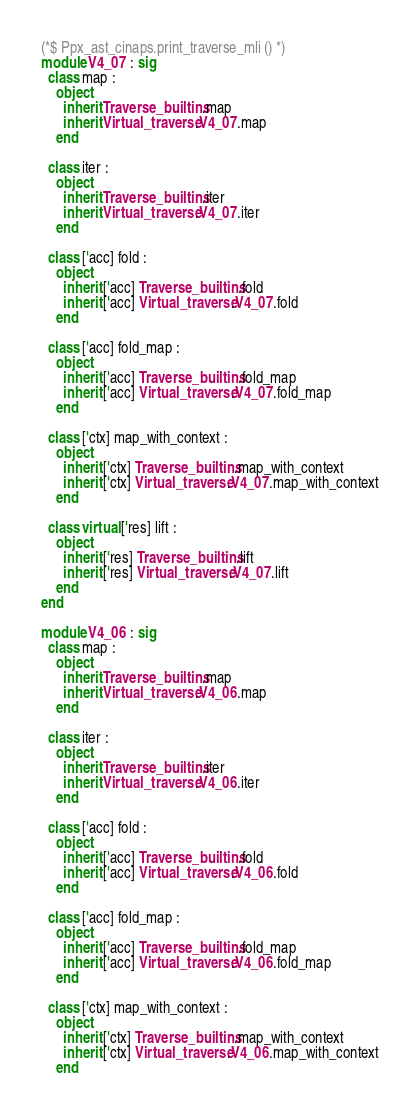Convert code to text. <code><loc_0><loc_0><loc_500><loc_500><_OCaml_>(*$ Ppx_ast_cinaps.print_traverse_mli () *)
module V4_07 : sig
  class map :
    object
      inherit Traverse_builtins.map
      inherit Virtual_traverse.V4_07.map
    end

  class iter :
    object
      inherit Traverse_builtins.iter
      inherit Virtual_traverse.V4_07.iter
    end

  class ['acc] fold :
    object
      inherit ['acc] Traverse_builtins.fold
      inherit ['acc] Virtual_traverse.V4_07.fold
    end

  class ['acc] fold_map :
    object
      inherit ['acc] Traverse_builtins.fold_map
      inherit ['acc] Virtual_traverse.V4_07.fold_map
    end

  class ['ctx] map_with_context :
    object
      inherit ['ctx] Traverse_builtins.map_with_context
      inherit ['ctx] Virtual_traverse.V4_07.map_with_context
    end

  class virtual ['res] lift :
    object
      inherit ['res] Traverse_builtins.lift
      inherit ['res] Virtual_traverse.V4_07.lift
    end
end

module V4_06 : sig
  class map :
    object
      inherit Traverse_builtins.map
      inherit Virtual_traverse.V4_06.map
    end

  class iter :
    object
      inherit Traverse_builtins.iter
      inherit Virtual_traverse.V4_06.iter
    end

  class ['acc] fold :
    object
      inherit ['acc] Traverse_builtins.fold
      inherit ['acc] Virtual_traverse.V4_06.fold
    end

  class ['acc] fold_map :
    object
      inherit ['acc] Traverse_builtins.fold_map
      inherit ['acc] Virtual_traverse.V4_06.fold_map
    end

  class ['ctx] map_with_context :
    object
      inherit ['ctx] Traverse_builtins.map_with_context
      inherit ['ctx] Virtual_traverse.V4_06.map_with_context
    end
</code> 